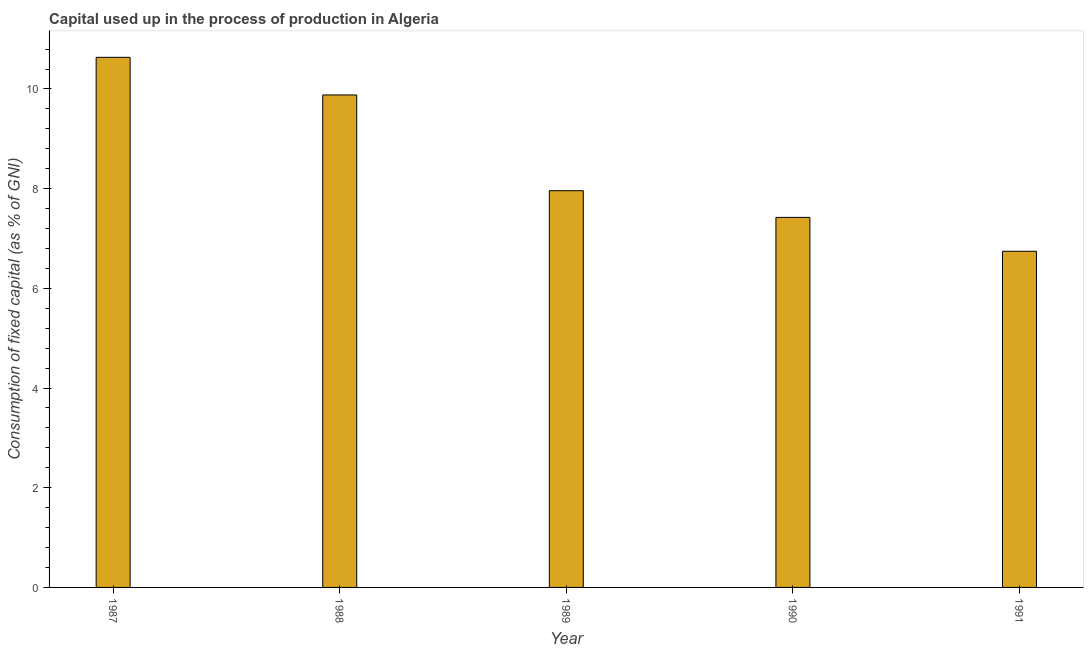What is the title of the graph?
Keep it short and to the point. Capital used up in the process of production in Algeria. What is the label or title of the Y-axis?
Your answer should be compact. Consumption of fixed capital (as % of GNI). What is the consumption of fixed capital in 1991?
Your answer should be compact. 6.74. Across all years, what is the maximum consumption of fixed capital?
Offer a very short reply. 10.64. Across all years, what is the minimum consumption of fixed capital?
Your answer should be compact. 6.74. What is the sum of the consumption of fixed capital?
Offer a very short reply. 42.64. What is the difference between the consumption of fixed capital in 1987 and 1990?
Offer a terse response. 3.21. What is the average consumption of fixed capital per year?
Provide a succinct answer. 8.53. What is the median consumption of fixed capital?
Give a very brief answer. 7.96. What is the ratio of the consumption of fixed capital in 1987 to that in 1988?
Your response must be concise. 1.08. What is the difference between the highest and the second highest consumption of fixed capital?
Keep it short and to the point. 0.76. What is the difference between the highest and the lowest consumption of fixed capital?
Your answer should be compact. 3.89. In how many years, is the consumption of fixed capital greater than the average consumption of fixed capital taken over all years?
Make the answer very short. 2. How many bars are there?
Provide a succinct answer. 5. How many years are there in the graph?
Keep it short and to the point. 5. What is the difference between two consecutive major ticks on the Y-axis?
Your answer should be compact. 2. What is the Consumption of fixed capital (as % of GNI) of 1987?
Offer a very short reply. 10.64. What is the Consumption of fixed capital (as % of GNI) of 1988?
Provide a succinct answer. 9.88. What is the Consumption of fixed capital (as % of GNI) in 1989?
Give a very brief answer. 7.96. What is the Consumption of fixed capital (as % of GNI) in 1990?
Keep it short and to the point. 7.42. What is the Consumption of fixed capital (as % of GNI) in 1991?
Your answer should be very brief. 6.74. What is the difference between the Consumption of fixed capital (as % of GNI) in 1987 and 1988?
Your answer should be compact. 0.75. What is the difference between the Consumption of fixed capital (as % of GNI) in 1987 and 1989?
Provide a succinct answer. 2.68. What is the difference between the Consumption of fixed capital (as % of GNI) in 1987 and 1990?
Give a very brief answer. 3.21. What is the difference between the Consumption of fixed capital (as % of GNI) in 1987 and 1991?
Provide a short and direct response. 3.89. What is the difference between the Consumption of fixed capital (as % of GNI) in 1988 and 1989?
Provide a short and direct response. 1.92. What is the difference between the Consumption of fixed capital (as % of GNI) in 1988 and 1990?
Offer a very short reply. 2.46. What is the difference between the Consumption of fixed capital (as % of GNI) in 1988 and 1991?
Provide a succinct answer. 3.14. What is the difference between the Consumption of fixed capital (as % of GNI) in 1989 and 1990?
Your answer should be very brief. 0.54. What is the difference between the Consumption of fixed capital (as % of GNI) in 1989 and 1991?
Provide a short and direct response. 1.22. What is the difference between the Consumption of fixed capital (as % of GNI) in 1990 and 1991?
Offer a very short reply. 0.68. What is the ratio of the Consumption of fixed capital (as % of GNI) in 1987 to that in 1988?
Your answer should be very brief. 1.08. What is the ratio of the Consumption of fixed capital (as % of GNI) in 1987 to that in 1989?
Your response must be concise. 1.34. What is the ratio of the Consumption of fixed capital (as % of GNI) in 1987 to that in 1990?
Your answer should be compact. 1.43. What is the ratio of the Consumption of fixed capital (as % of GNI) in 1987 to that in 1991?
Offer a terse response. 1.58. What is the ratio of the Consumption of fixed capital (as % of GNI) in 1988 to that in 1989?
Keep it short and to the point. 1.24. What is the ratio of the Consumption of fixed capital (as % of GNI) in 1988 to that in 1990?
Provide a succinct answer. 1.33. What is the ratio of the Consumption of fixed capital (as % of GNI) in 1988 to that in 1991?
Keep it short and to the point. 1.47. What is the ratio of the Consumption of fixed capital (as % of GNI) in 1989 to that in 1990?
Provide a short and direct response. 1.07. What is the ratio of the Consumption of fixed capital (as % of GNI) in 1989 to that in 1991?
Provide a short and direct response. 1.18. What is the ratio of the Consumption of fixed capital (as % of GNI) in 1990 to that in 1991?
Ensure brevity in your answer.  1.1. 